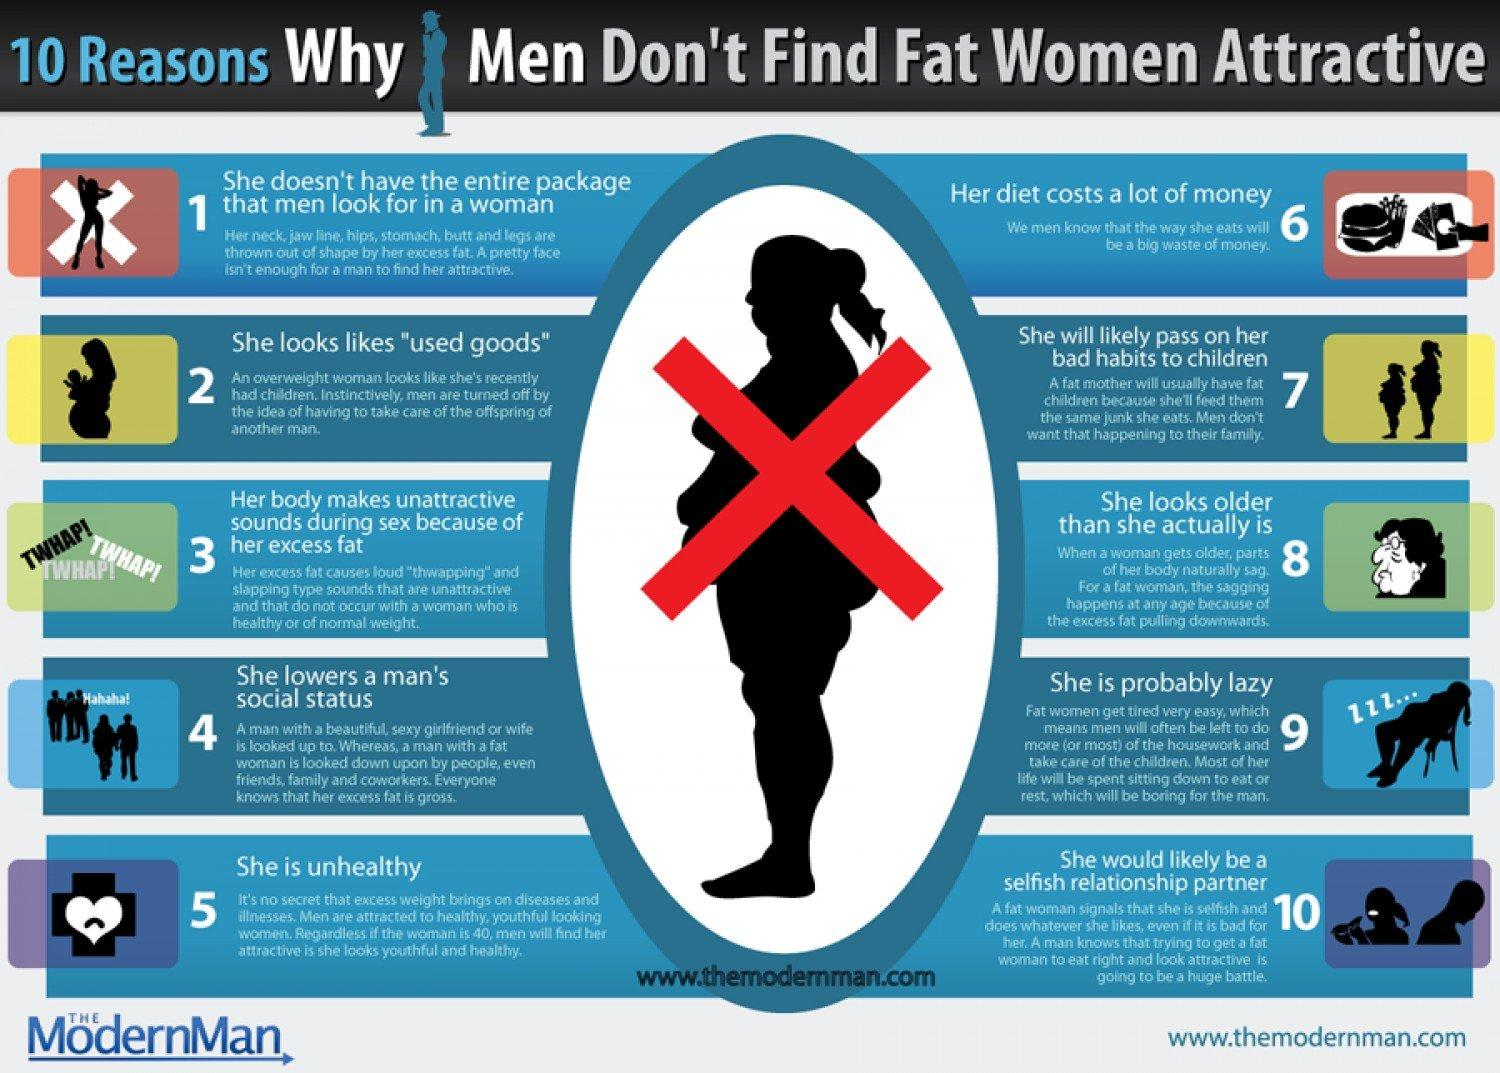Highlight a few significant elements in this photo. It is my firm belief that fat women often appear to be older than they actually are. 